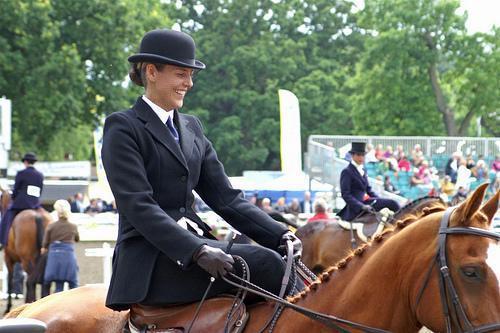How many old men are riding on horse?
Give a very brief answer. 0. 